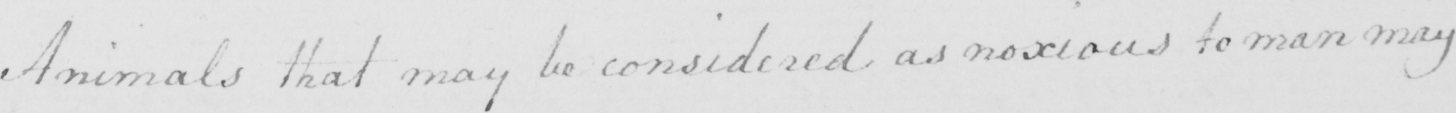Transcribe the text shown in this historical manuscript line. Animals that may be considered as noxious to man may 